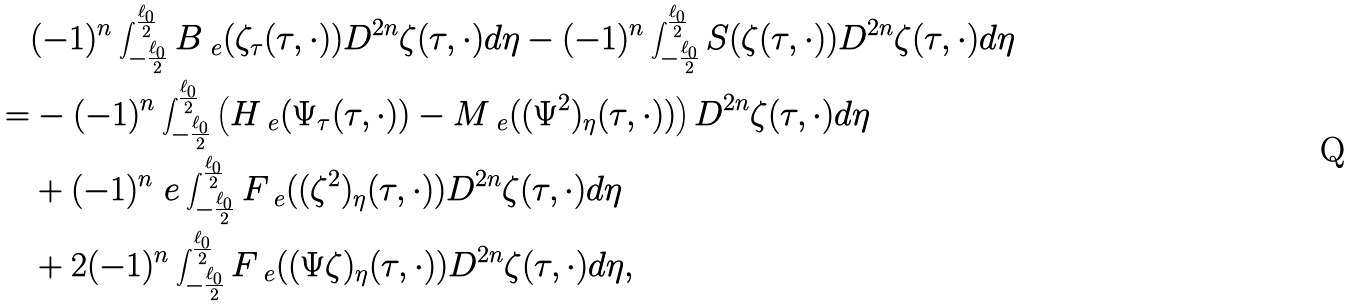Convert formula to latex. <formula><loc_0><loc_0><loc_500><loc_500>& ( - 1 ) ^ { n } \int _ { - \frac { \ell _ { 0 } } { 2 } } ^ { \frac { \ell _ { 0 } } { 2 } } B _ { \ e } ( \zeta _ { \tau } ( \tau , \cdot ) ) D ^ { 2 n } \zeta ( \tau , \cdot ) d \eta - ( - 1 ) ^ { n } \int _ { - \frac { \ell _ { 0 } } { 2 } } ^ { \frac { \ell _ { 0 } } { 2 } } S ( \zeta ( \tau , \cdot ) ) D ^ { 2 n } \zeta ( \tau , \cdot ) d \eta \\ = & - ( - 1 ) ^ { n } \int _ { - \frac { \ell _ { 0 } } { 2 } } ^ { \frac { \ell _ { 0 } } { 2 } } \left ( H _ { \ e } ( \Psi _ { \tau } ( \tau , \cdot ) ) - M _ { \ e } ( ( \Psi ^ { 2 } ) _ { \eta } ( \tau , \cdot ) ) \right ) D ^ { 2 n } \zeta ( \tau , \cdot ) d \eta \\ & + ( - 1 ) ^ { n } \ e \int _ { - \frac { \ell _ { 0 } } { 2 } } ^ { \frac { \ell _ { 0 } } { 2 } } F _ { \ e } ( ( \zeta ^ { 2 } ) _ { \eta } ( \tau , \cdot ) ) D ^ { 2 n } \zeta ( \tau , \cdot ) d \eta \\ & + 2 ( - 1 ) ^ { n } \int _ { - \frac { \ell _ { 0 } } { 2 } } ^ { \frac { \ell _ { 0 } } { 2 } } F _ { \ e } ( ( \Psi \zeta ) _ { \eta } ( \tau , \cdot ) ) D ^ { 2 n } \zeta ( \tau , \cdot ) d \eta ,</formula> 